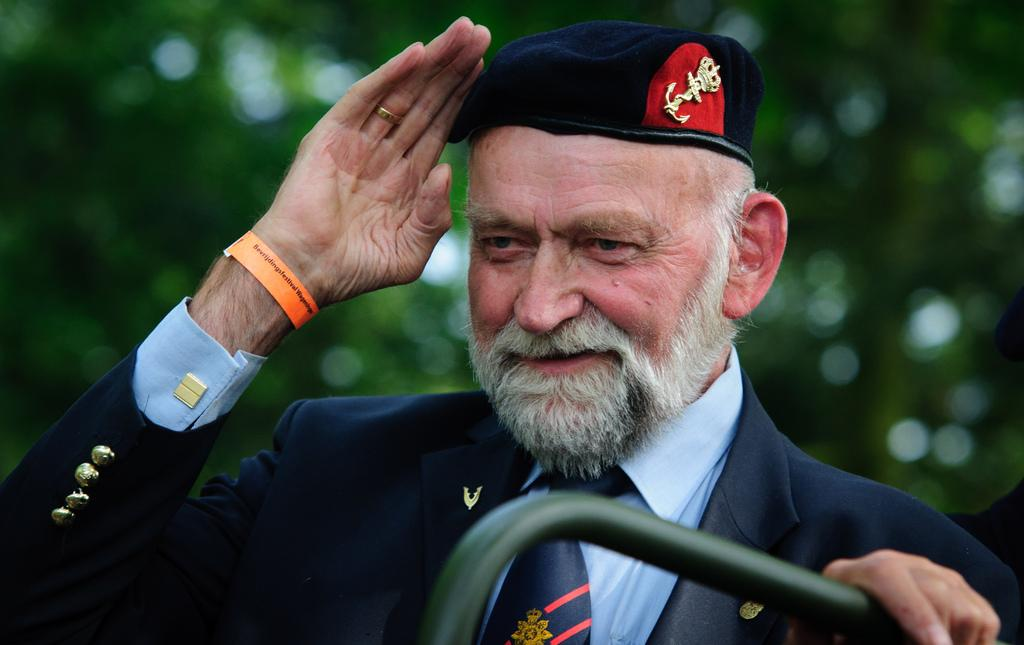What can be seen in the image? There is a person in the image. Can you describe the person's attire? The person is wearing a cap. What is the handle visible at the bottom of the image attached to? The facts do not provide enough information to determine what the handle is attached to. How would you describe the background of the image? The background of the image appears green and blurry. What type of straw is the person using to drink from the vase in the image? There is no vase or straw present in the image. How does the person show care for the environment in the image? The facts provided do not give any information about the person's actions or environmental concerns. 